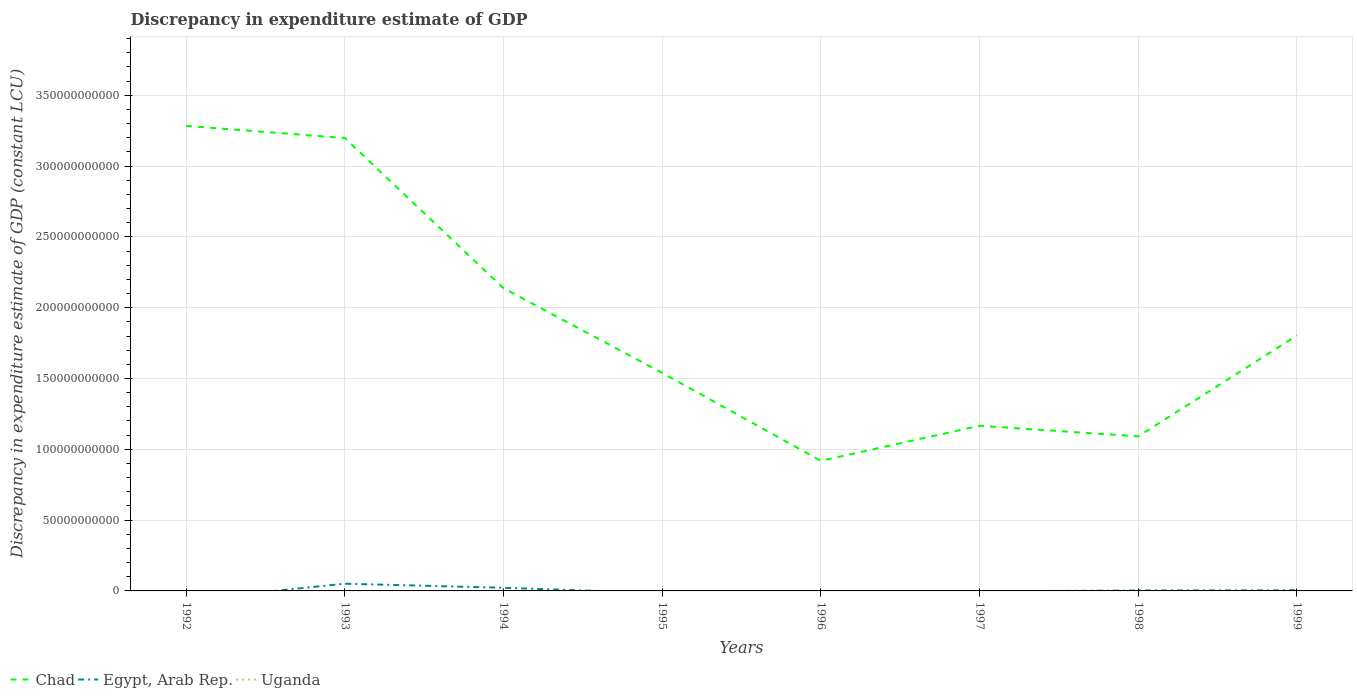Across all years, what is the maximum discrepancy in expenditure estimate of GDP in Egypt, Arab Rep.?
Give a very brief answer. 0. What is the total discrepancy in expenditure estimate of GDP in Chad in the graph?
Offer a terse response. 7.52e+09. What is the difference between the highest and the second highest discrepancy in expenditure estimate of GDP in Chad?
Offer a very short reply. 2.37e+11. How many years are there in the graph?
Your response must be concise. 8. What is the difference between two consecutive major ticks on the Y-axis?
Your response must be concise. 5.00e+1. Are the values on the major ticks of Y-axis written in scientific E-notation?
Your answer should be compact. No. Does the graph contain grids?
Offer a very short reply. Yes. Where does the legend appear in the graph?
Offer a very short reply. Bottom left. How many legend labels are there?
Your answer should be very brief. 3. How are the legend labels stacked?
Give a very brief answer. Horizontal. What is the title of the graph?
Provide a short and direct response. Discrepancy in expenditure estimate of GDP. Does "Australia" appear as one of the legend labels in the graph?
Your response must be concise. No. What is the label or title of the X-axis?
Offer a very short reply. Years. What is the label or title of the Y-axis?
Your answer should be very brief. Discrepancy in expenditure estimate of GDP (constant LCU). What is the Discrepancy in expenditure estimate of GDP (constant LCU) of Chad in 1992?
Your answer should be very brief. 3.28e+11. What is the Discrepancy in expenditure estimate of GDP (constant LCU) in Egypt, Arab Rep. in 1992?
Offer a terse response. 0. What is the Discrepancy in expenditure estimate of GDP (constant LCU) of Chad in 1993?
Offer a very short reply. 3.20e+11. What is the Discrepancy in expenditure estimate of GDP (constant LCU) in Egypt, Arab Rep. in 1993?
Give a very brief answer. 5.11e+09. What is the Discrepancy in expenditure estimate of GDP (constant LCU) of Chad in 1994?
Offer a terse response. 2.14e+11. What is the Discrepancy in expenditure estimate of GDP (constant LCU) of Egypt, Arab Rep. in 1994?
Keep it short and to the point. 2.23e+09. What is the Discrepancy in expenditure estimate of GDP (constant LCU) in Uganda in 1994?
Your answer should be very brief. 0. What is the Discrepancy in expenditure estimate of GDP (constant LCU) in Chad in 1995?
Your answer should be very brief. 1.54e+11. What is the Discrepancy in expenditure estimate of GDP (constant LCU) in Uganda in 1995?
Ensure brevity in your answer.  0. What is the Discrepancy in expenditure estimate of GDP (constant LCU) in Chad in 1996?
Your answer should be very brief. 9.19e+1. What is the Discrepancy in expenditure estimate of GDP (constant LCU) of Egypt, Arab Rep. in 1996?
Offer a very short reply. 0. What is the Discrepancy in expenditure estimate of GDP (constant LCU) of Chad in 1997?
Provide a short and direct response. 1.17e+11. What is the Discrepancy in expenditure estimate of GDP (constant LCU) of Egypt, Arab Rep. in 1997?
Your response must be concise. 0. What is the Discrepancy in expenditure estimate of GDP (constant LCU) of Chad in 1998?
Your answer should be compact. 1.09e+11. What is the Discrepancy in expenditure estimate of GDP (constant LCU) of Egypt, Arab Rep. in 1998?
Give a very brief answer. 2.98e+08. What is the Discrepancy in expenditure estimate of GDP (constant LCU) of Chad in 1999?
Give a very brief answer. 1.80e+11. What is the Discrepancy in expenditure estimate of GDP (constant LCU) in Egypt, Arab Rep. in 1999?
Your answer should be very brief. 4.60e+08. Across all years, what is the maximum Discrepancy in expenditure estimate of GDP (constant LCU) in Chad?
Make the answer very short. 3.28e+11. Across all years, what is the maximum Discrepancy in expenditure estimate of GDP (constant LCU) of Egypt, Arab Rep.?
Your answer should be compact. 5.11e+09. Across all years, what is the minimum Discrepancy in expenditure estimate of GDP (constant LCU) in Chad?
Offer a terse response. 9.19e+1. Across all years, what is the minimum Discrepancy in expenditure estimate of GDP (constant LCU) in Egypt, Arab Rep.?
Offer a very short reply. 0. What is the total Discrepancy in expenditure estimate of GDP (constant LCU) of Chad in the graph?
Offer a terse response. 1.51e+12. What is the total Discrepancy in expenditure estimate of GDP (constant LCU) in Egypt, Arab Rep. in the graph?
Your response must be concise. 8.09e+09. What is the total Discrepancy in expenditure estimate of GDP (constant LCU) of Uganda in the graph?
Make the answer very short. 0. What is the difference between the Discrepancy in expenditure estimate of GDP (constant LCU) in Chad in 1992 and that in 1993?
Provide a succinct answer. 8.57e+09. What is the difference between the Discrepancy in expenditure estimate of GDP (constant LCU) in Chad in 1992 and that in 1994?
Offer a terse response. 1.15e+11. What is the difference between the Discrepancy in expenditure estimate of GDP (constant LCU) of Chad in 1992 and that in 1995?
Your response must be concise. 1.74e+11. What is the difference between the Discrepancy in expenditure estimate of GDP (constant LCU) in Chad in 1992 and that in 1996?
Keep it short and to the point. 2.37e+11. What is the difference between the Discrepancy in expenditure estimate of GDP (constant LCU) of Chad in 1992 and that in 1997?
Offer a very short reply. 2.12e+11. What is the difference between the Discrepancy in expenditure estimate of GDP (constant LCU) in Chad in 1992 and that in 1998?
Offer a terse response. 2.19e+11. What is the difference between the Discrepancy in expenditure estimate of GDP (constant LCU) in Chad in 1992 and that in 1999?
Offer a very short reply. 1.48e+11. What is the difference between the Discrepancy in expenditure estimate of GDP (constant LCU) in Chad in 1993 and that in 1994?
Keep it short and to the point. 1.06e+11. What is the difference between the Discrepancy in expenditure estimate of GDP (constant LCU) of Egypt, Arab Rep. in 1993 and that in 1994?
Ensure brevity in your answer.  2.88e+09. What is the difference between the Discrepancy in expenditure estimate of GDP (constant LCU) in Chad in 1993 and that in 1995?
Your answer should be compact. 1.66e+11. What is the difference between the Discrepancy in expenditure estimate of GDP (constant LCU) of Chad in 1993 and that in 1996?
Provide a short and direct response. 2.28e+11. What is the difference between the Discrepancy in expenditure estimate of GDP (constant LCU) of Chad in 1993 and that in 1997?
Your response must be concise. 2.03e+11. What is the difference between the Discrepancy in expenditure estimate of GDP (constant LCU) in Chad in 1993 and that in 1998?
Give a very brief answer. 2.11e+11. What is the difference between the Discrepancy in expenditure estimate of GDP (constant LCU) of Egypt, Arab Rep. in 1993 and that in 1998?
Ensure brevity in your answer.  4.81e+09. What is the difference between the Discrepancy in expenditure estimate of GDP (constant LCU) in Chad in 1993 and that in 1999?
Provide a succinct answer. 1.39e+11. What is the difference between the Discrepancy in expenditure estimate of GDP (constant LCU) of Egypt, Arab Rep. in 1993 and that in 1999?
Give a very brief answer. 4.65e+09. What is the difference between the Discrepancy in expenditure estimate of GDP (constant LCU) of Chad in 1994 and that in 1995?
Your response must be concise. 5.98e+1. What is the difference between the Discrepancy in expenditure estimate of GDP (constant LCU) of Chad in 1994 and that in 1996?
Your answer should be very brief. 1.22e+11. What is the difference between the Discrepancy in expenditure estimate of GDP (constant LCU) of Chad in 1994 and that in 1997?
Offer a very short reply. 9.71e+1. What is the difference between the Discrepancy in expenditure estimate of GDP (constant LCU) in Chad in 1994 and that in 1998?
Your answer should be very brief. 1.05e+11. What is the difference between the Discrepancy in expenditure estimate of GDP (constant LCU) of Egypt, Arab Rep. in 1994 and that in 1998?
Provide a short and direct response. 1.93e+09. What is the difference between the Discrepancy in expenditure estimate of GDP (constant LCU) of Chad in 1994 and that in 1999?
Offer a terse response. 3.34e+1. What is the difference between the Discrepancy in expenditure estimate of GDP (constant LCU) in Egypt, Arab Rep. in 1994 and that in 1999?
Keep it short and to the point. 1.77e+09. What is the difference between the Discrepancy in expenditure estimate of GDP (constant LCU) of Chad in 1995 and that in 1996?
Your answer should be very brief. 6.21e+1. What is the difference between the Discrepancy in expenditure estimate of GDP (constant LCU) in Chad in 1995 and that in 1997?
Your answer should be compact. 3.74e+1. What is the difference between the Discrepancy in expenditure estimate of GDP (constant LCU) in Chad in 1995 and that in 1998?
Keep it short and to the point. 4.49e+1. What is the difference between the Discrepancy in expenditure estimate of GDP (constant LCU) of Chad in 1995 and that in 1999?
Ensure brevity in your answer.  -2.64e+1. What is the difference between the Discrepancy in expenditure estimate of GDP (constant LCU) in Chad in 1996 and that in 1997?
Ensure brevity in your answer.  -2.48e+1. What is the difference between the Discrepancy in expenditure estimate of GDP (constant LCU) of Chad in 1996 and that in 1998?
Offer a very short reply. -1.72e+1. What is the difference between the Discrepancy in expenditure estimate of GDP (constant LCU) in Chad in 1996 and that in 1999?
Keep it short and to the point. -8.85e+1. What is the difference between the Discrepancy in expenditure estimate of GDP (constant LCU) of Chad in 1997 and that in 1998?
Keep it short and to the point. 7.52e+09. What is the difference between the Discrepancy in expenditure estimate of GDP (constant LCU) in Chad in 1997 and that in 1999?
Your answer should be very brief. -6.38e+1. What is the difference between the Discrepancy in expenditure estimate of GDP (constant LCU) in Chad in 1998 and that in 1999?
Your answer should be very brief. -7.13e+1. What is the difference between the Discrepancy in expenditure estimate of GDP (constant LCU) in Egypt, Arab Rep. in 1998 and that in 1999?
Give a very brief answer. -1.62e+08. What is the difference between the Discrepancy in expenditure estimate of GDP (constant LCU) of Chad in 1992 and the Discrepancy in expenditure estimate of GDP (constant LCU) of Egypt, Arab Rep. in 1993?
Ensure brevity in your answer.  3.23e+11. What is the difference between the Discrepancy in expenditure estimate of GDP (constant LCU) in Chad in 1992 and the Discrepancy in expenditure estimate of GDP (constant LCU) in Egypt, Arab Rep. in 1994?
Your response must be concise. 3.26e+11. What is the difference between the Discrepancy in expenditure estimate of GDP (constant LCU) in Chad in 1992 and the Discrepancy in expenditure estimate of GDP (constant LCU) in Egypt, Arab Rep. in 1998?
Ensure brevity in your answer.  3.28e+11. What is the difference between the Discrepancy in expenditure estimate of GDP (constant LCU) in Chad in 1992 and the Discrepancy in expenditure estimate of GDP (constant LCU) in Egypt, Arab Rep. in 1999?
Provide a short and direct response. 3.28e+11. What is the difference between the Discrepancy in expenditure estimate of GDP (constant LCU) in Chad in 1993 and the Discrepancy in expenditure estimate of GDP (constant LCU) in Egypt, Arab Rep. in 1994?
Make the answer very short. 3.18e+11. What is the difference between the Discrepancy in expenditure estimate of GDP (constant LCU) in Chad in 1993 and the Discrepancy in expenditure estimate of GDP (constant LCU) in Egypt, Arab Rep. in 1998?
Your response must be concise. 3.20e+11. What is the difference between the Discrepancy in expenditure estimate of GDP (constant LCU) in Chad in 1993 and the Discrepancy in expenditure estimate of GDP (constant LCU) in Egypt, Arab Rep. in 1999?
Provide a short and direct response. 3.19e+11. What is the difference between the Discrepancy in expenditure estimate of GDP (constant LCU) of Chad in 1994 and the Discrepancy in expenditure estimate of GDP (constant LCU) of Egypt, Arab Rep. in 1998?
Your answer should be very brief. 2.13e+11. What is the difference between the Discrepancy in expenditure estimate of GDP (constant LCU) of Chad in 1994 and the Discrepancy in expenditure estimate of GDP (constant LCU) of Egypt, Arab Rep. in 1999?
Your response must be concise. 2.13e+11. What is the difference between the Discrepancy in expenditure estimate of GDP (constant LCU) in Chad in 1995 and the Discrepancy in expenditure estimate of GDP (constant LCU) in Egypt, Arab Rep. in 1998?
Your answer should be compact. 1.54e+11. What is the difference between the Discrepancy in expenditure estimate of GDP (constant LCU) in Chad in 1995 and the Discrepancy in expenditure estimate of GDP (constant LCU) in Egypt, Arab Rep. in 1999?
Give a very brief answer. 1.54e+11. What is the difference between the Discrepancy in expenditure estimate of GDP (constant LCU) in Chad in 1996 and the Discrepancy in expenditure estimate of GDP (constant LCU) in Egypt, Arab Rep. in 1998?
Offer a terse response. 9.16e+1. What is the difference between the Discrepancy in expenditure estimate of GDP (constant LCU) in Chad in 1996 and the Discrepancy in expenditure estimate of GDP (constant LCU) in Egypt, Arab Rep. in 1999?
Ensure brevity in your answer.  9.14e+1. What is the difference between the Discrepancy in expenditure estimate of GDP (constant LCU) in Chad in 1997 and the Discrepancy in expenditure estimate of GDP (constant LCU) in Egypt, Arab Rep. in 1998?
Give a very brief answer. 1.16e+11. What is the difference between the Discrepancy in expenditure estimate of GDP (constant LCU) in Chad in 1997 and the Discrepancy in expenditure estimate of GDP (constant LCU) in Egypt, Arab Rep. in 1999?
Your answer should be compact. 1.16e+11. What is the difference between the Discrepancy in expenditure estimate of GDP (constant LCU) of Chad in 1998 and the Discrepancy in expenditure estimate of GDP (constant LCU) of Egypt, Arab Rep. in 1999?
Offer a terse response. 1.09e+11. What is the average Discrepancy in expenditure estimate of GDP (constant LCU) in Chad per year?
Offer a terse response. 1.89e+11. What is the average Discrepancy in expenditure estimate of GDP (constant LCU) in Egypt, Arab Rep. per year?
Keep it short and to the point. 1.01e+09. What is the average Discrepancy in expenditure estimate of GDP (constant LCU) of Uganda per year?
Offer a very short reply. 0. In the year 1993, what is the difference between the Discrepancy in expenditure estimate of GDP (constant LCU) of Chad and Discrepancy in expenditure estimate of GDP (constant LCU) of Egypt, Arab Rep.?
Keep it short and to the point. 3.15e+11. In the year 1994, what is the difference between the Discrepancy in expenditure estimate of GDP (constant LCU) in Chad and Discrepancy in expenditure estimate of GDP (constant LCU) in Egypt, Arab Rep.?
Offer a very short reply. 2.12e+11. In the year 1998, what is the difference between the Discrepancy in expenditure estimate of GDP (constant LCU) of Chad and Discrepancy in expenditure estimate of GDP (constant LCU) of Egypt, Arab Rep.?
Ensure brevity in your answer.  1.09e+11. In the year 1999, what is the difference between the Discrepancy in expenditure estimate of GDP (constant LCU) in Chad and Discrepancy in expenditure estimate of GDP (constant LCU) in Egypt, Arab Rep.?
Provide a succinct answer. 1.80e+11. What is the ratio of the Discrepancy in expenditure estimate of GDP (constant LCU) in Chad in 1992 to that in 1993?
Your response must be concise. 1.03. What is the ratio of the Discrepancy in expenditure estimate of GDP (constant LCU) in Chad in 1992 to that in 1994?
Your response must be concise. 1.54. What is the ratio of the Discrepancy in expenditure estimate of GDP (constant LCU) in Chad in 1992 to that in 1995?
Provide a short and direct response. 2.13. What is the ratio of the Discrepancy in expenditure estimate of GDP (constant LCU) of Chad in 1992 to that in 1996?
Give a very brief answer. 3.57. What is the ratio of the Discrepancy in expenditure estimate of GDP (constant LCU) of Chad in 1992 to that in 1997?
Provide a succinct answer. 2.82. What is the ratio of the Discrepancy in expenditure estimate of GDP (constant LCU) in Chad in 1992 to that in 1998?
Provide a succinct answer. 3.01. What is the ratio of the Discrepancy in expenditure estimate of GDP (constant LCU) of Chad in 1992 to that in 1999?
Your answer should be compact. 1.82. What is the ratio of the Discrepancy in expenditure estimate of GDP (constant LCU) in Chad in 1993 to that in 1994?
Ensure brevity in your answer.  1.5. What is the ratio of the Discrepancy in expenditure estimate of GDP (constant LCU) of Egypt, Arab Rep. in 1993 to that in 1994?
Ensure brevity in your answer.  2.29. What is the ratio of the Discrepancy in expenditure estimate of GDP (constant LCU) of Chad in 1993 to that in 1995?
Make the answer very short. 2.08. What is the ratio of the Discrepancy in expenditure estimate of GDP (constant LCU) of Chad in 1993 to that in 1996?
Your response must be concise. 3.48. What is the ratio of the Discrepancy in expenditure estimate of GDP (constant LCU) of Chad in 1993 to that in 1997?
Your response must be concise. 2.74. What is the ratio of the Discrepancy in expenditure estimate of GDP (constant LCU) in Chad in 1993 to that in 1998?
Provide a short and direct response. 2.93. What is the ratio of the Discrepancy in expenditure estimate of GDP (constant LCU) in Egypt, Arab Rep. in 1993 to that in 1998?
Your answer should be very brief. 17.14. What is the ratio of the Discrepancy in expenditure estimate of GDP (constant LCU) of Chad in 1993 to that in 1999?
Offer a terse response. 1.77. What is the ratio of the Discrepancy in expenditure estimate of GDP (constant LCU) in Egypt, Arab Rep. in 1993 to that in 1999?
Your answer should be very brief. 11.11. What is the ratio of the Discrepancy in expenditure estimate of GDP (constant LCU) in Chad in 1994 to that in 1995?
Ensure brevity in your answer.  1.39. What is the ratio of the Discrepancy in expenditure estimate of GDP (constant LCU) in Chad in 1994 to that in 1996?
Your response must be concise. 2.33. What is the ratio of the Discrepancy in expenditure estimate of GDP (constant LCU) in Chad in 1994 to that in 1997?
Your answer should be compact. 1.83. What is the ratio of the Discrepancy in expenditure estimate of GDP (constant LCU) in Chad in 1994 to that in 1998?
Provide a succinct answer. 1.96. What is the ratio of the Discrepancy in expenditure estimate of GDP (constant LCU) in Egypt, Arab Rep. in 1994 to that in 1998?
Your answer should be compact. 7.48. What is the ratio of the Discrepancy in expenditure estimate of GDP (constant LCU) of Chad in 1994 to that in 1999?
Provide a short and direct response. 1.18. What is the ratio of the Discrepancy in expenditure estimate of GDP (constant LCU) in Egypt, Arab Rep. in 1994 to that in 1999?
Keep it short and to the point. 4.85. What is the ratio of the Discrepancy in expenditure estimate of GDP (constant LCU) of Chad in 1995 to that in 1996?
Provide a succinct answer. 1.68. What is the ratio of the Discrepancy in expenditure estimate of GDP (constant LCU) of Chad in 1995 to that in 1997?
Offer a terse response. 1.32. What is the ratio of the Discrepancy in expenditure estimate of GDP (constant LCU) of Chad in 1995 to that in 1998?
Keep it short and to the point. 1.41. What is the ratio of the Discrepancy in expenditure estimate of GDP (constant LCU) in Chad in 1995 to that in 1999?
Provide a succinct answer. 0.85. What is the ratio of the Discrepancy in expenditure estimate of GDP (constant LCU) of Chad in 1996 to that in 1997?
Offer a terse response. 0.79. What is the ratio of the Discrepancy in expenditure estimate of GDP (constant LCU) in Chad in 1996 to that in 1998?
Give a very brief answer. 0.84. What is the ratio of the Discrepancy in expenditure estimate of GDP (constant LCU) of Chad in 1996 to that in 1999?
Ensure brevity in your answer.  0.51. What is the ratio of the Discrepancy in expenditure estimate of GDP (constant LCU) of Chad in 1997 to that in 1998?
Offer a terse response. 1.07. What is the ratio of the Discrepancy in expenditure estimate of GDP (constant LCU) in Chad in 1997 to that in 1999?
Your answer should be very brief. 0.65. What is the ratio of the Discrepancy in expenditure estimate of GDP (constant LCU) in Chad in 1998 to that in 1999?
Keep it short and to the point. 0.6. What is the ratio of the Discrepancy in expenditure estimate of GDP (constant LCU) of Egypt, Arab Rep. in 1998 to that in 1999?
Keep it short and to the point. 0.65. What is the difference between the highest and the second highest Discrepancy in expenditure estimate of GDP (constant LCU) in Chad?
Provide a succinct answer. 8.57e+09. What is the difference between the highest and the second highest Discrepancy in expenditure estimate of GDP (constant LCU) in Egypt, Arab Rep.?
Offer a terse response. 2.88e+09. What is the difference between the highest and the lowest Discrepancy in expenditure estimate of GDP (constant LCU) in Chad?
Provide a short and direct response. 2.37e+11. What is the difference between the highest and the lowest Discrepancy in expenditure estimate of GDP (constant LCU) of Egypt, Arab Rep.?
Offer a terse response. 5.11e+09. 